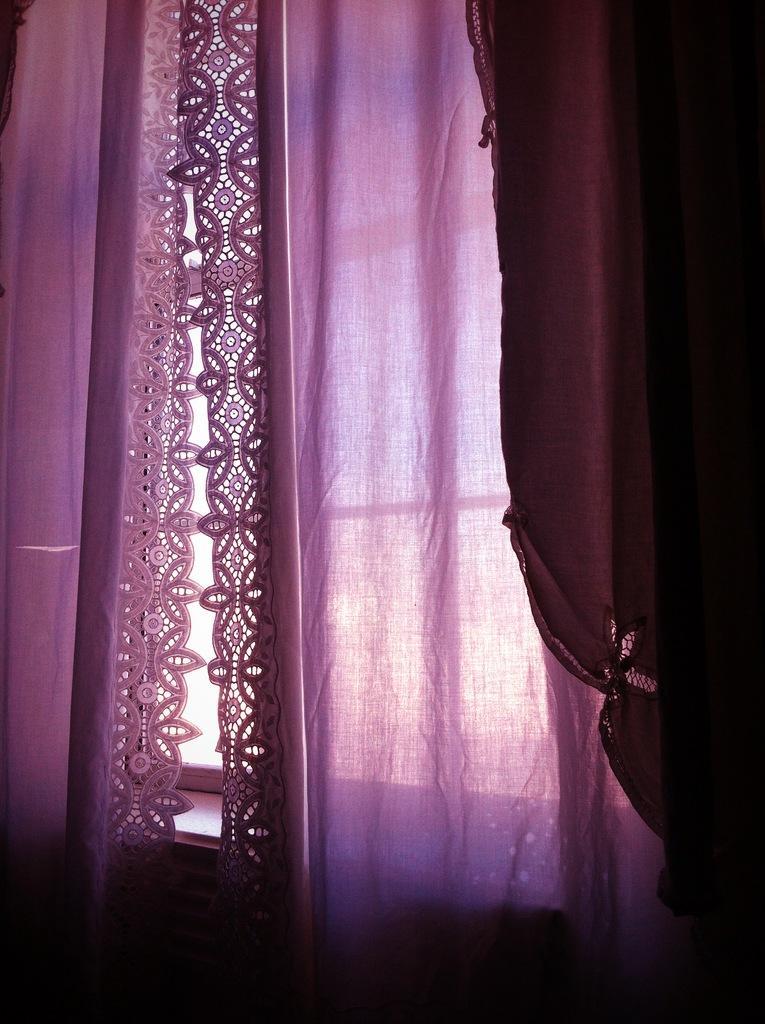How would you summarize this image in a sentence or two? In this picture there is a window in the center of the image with a curtain. 